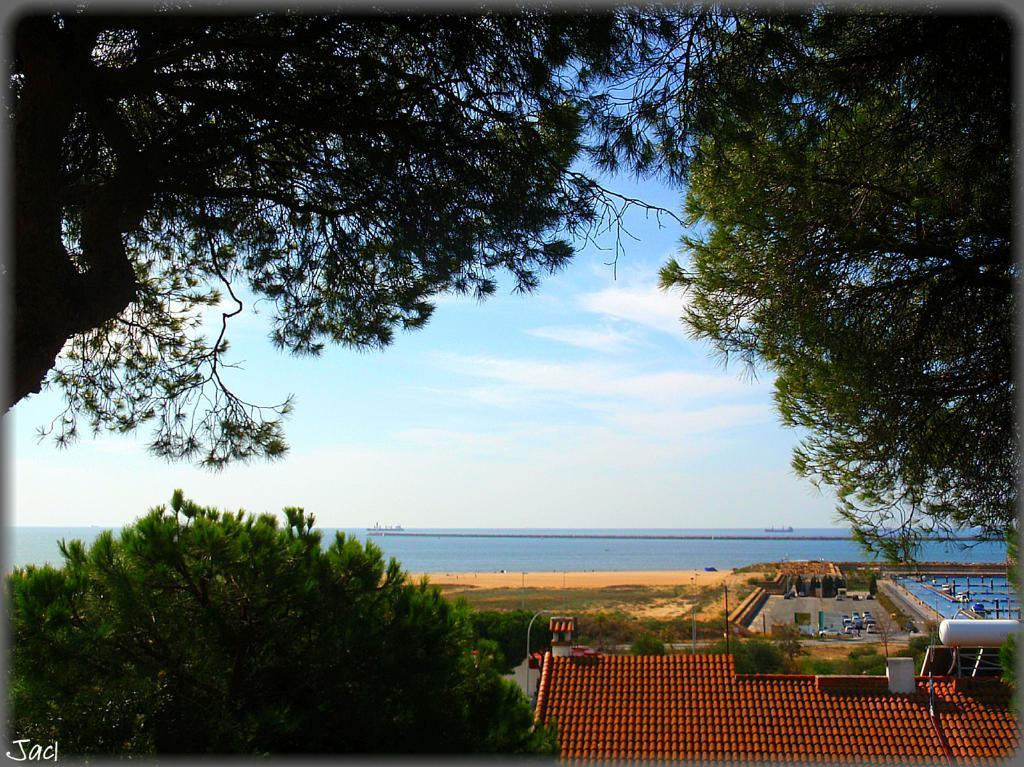What is located at the bottom of the image? There is a tree at the bottom of the image. What type of structure can be seen in the image? There is a house in the image. What can be seen in the background of the image? Water and sky are visible in the background of the image. What type of vegetation is present on both sides of the image? There are trees on both sides of the image. Can you tell me how many snails are crawling on the tree in the image? There are no snails visible on the tree in the image. What type of bird is seen flying in a flock over the house in the image? There is no flock of birds or any birds visible in the image. 